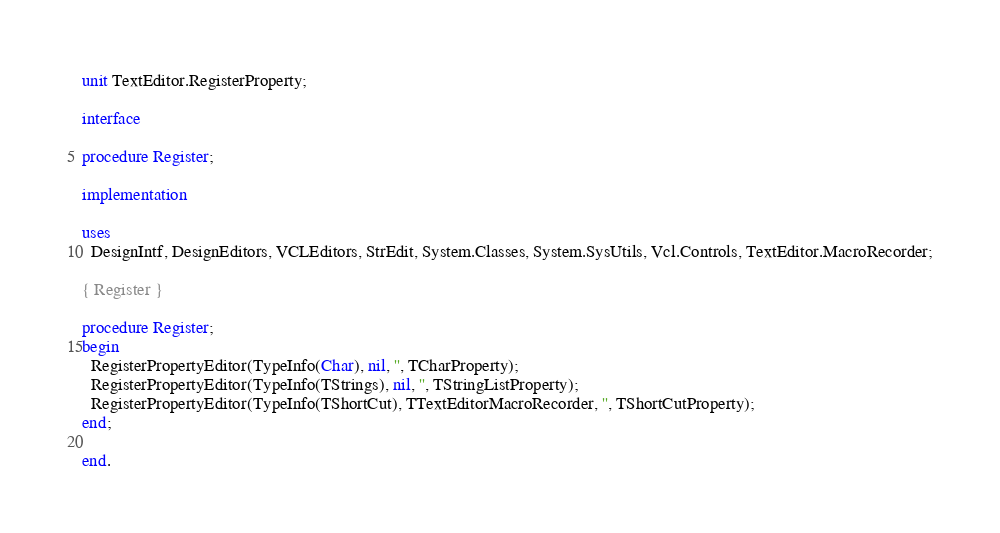Convert code to text. <code><loc_0><loc_0><loc_500><loc_500><_Pascal_>unit TextEditor.RegisterProperty;

interface

procedure Register;

implementation

uses
  DesignIntf, DesignEditors, VCLEditors, StrEdit, System.Classes, System.SysUtils, Vcl.Controls, TextEditor.MacroRecorder;

{ Register }

procedure Register;
begin
  RegisterPropertyEditor(TypeInfo(Char), nil, '', TCharProperty);
  RegisterPropertyEditor(TypeInfo(TStrings), nil, '', TStringListProperty);
  RegisterPropertyEditor(TypeInfo(TShortCut), TTextEditorMacroRecorder, '', TShortCutProperty);
end;

end.
</code> 